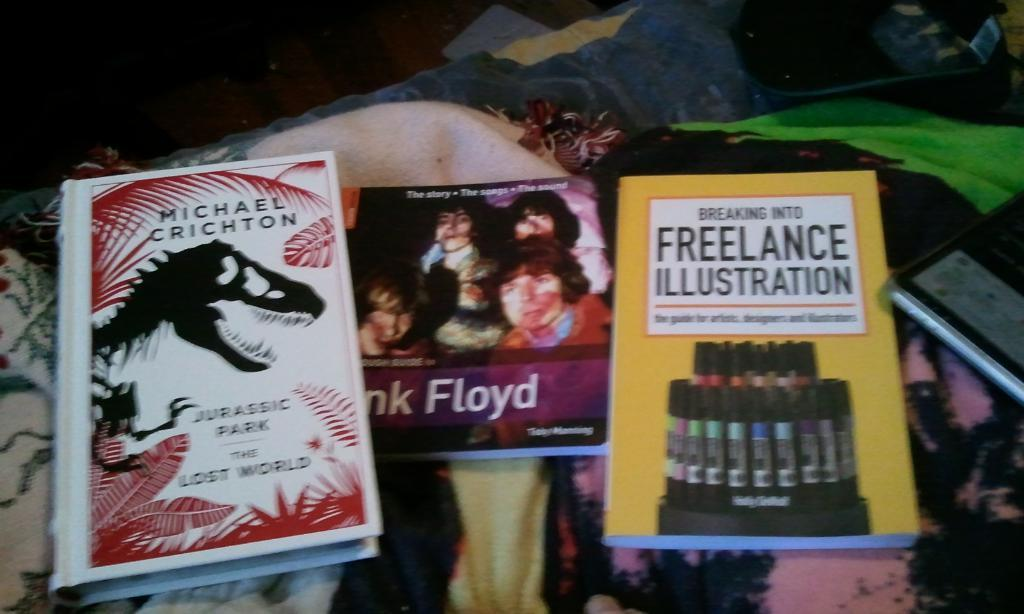Provide a one-sentence caption for the provided image. Three books on a table that are Jurassic Park, Pink Floyd and Freelance Illustration. 